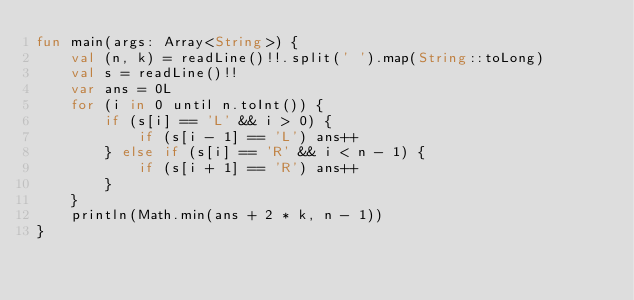Convert code to text. <code><loc_0><loc_0><loc_500><loc_500><_Kotlin_>fun main(args: Array<String>) {
    val (n, k) = readLine()!!.split(' ').map(String::toLong)
    val s = readLine()!!
    var ans = 0L
    for (i in 0 until n.toInt()) {
        if (s[i] == 'L' && i > 0) {
            if (s[i - 1] == 'L') ans++
        } else if (s[i] == 'R' && i < n - 1) {
            if (s[i + 1] == 'R') ans++
        }
    }
    println(Math.min(ans + 2 * k, n - 1))
}</code> 